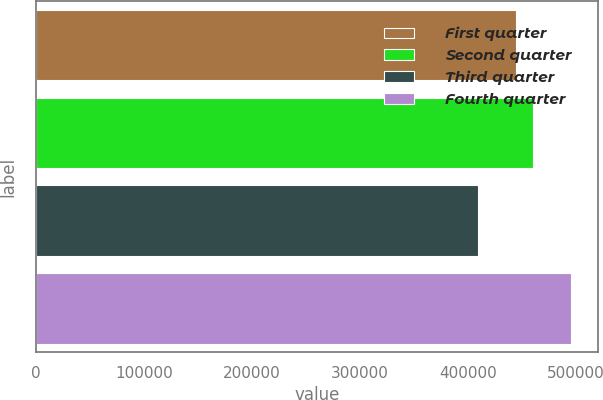<chart> <loc_0><loc_0><loc_500><loc_500><bar_chart><fcel>First quarter<fcel>Second quarter<fcel>Third quarter<fcel>Fourth quarter<nl><fcel>444605<fcel>459556<fcel>409390<fcel>495030<nl></chart> 